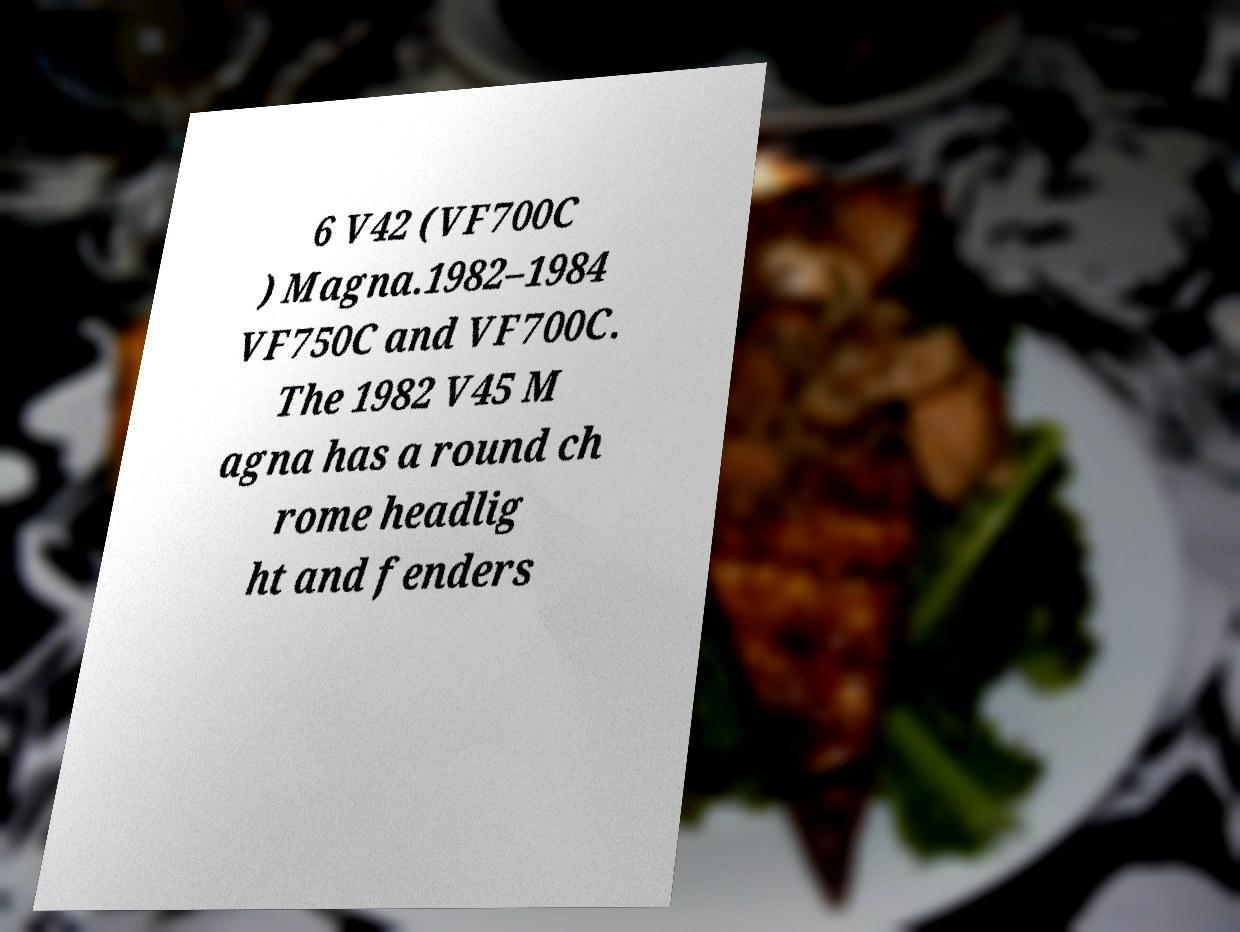Can you read and provide the text displayed in the image?This photo seems to have some interesting text. Can you extract and type it out for me? 6 V42 (VF700C ) Magna.1982–1984 VF750C and VF700C. The 1982 V45 M agna has a round ch rome headlig ht and fenders 